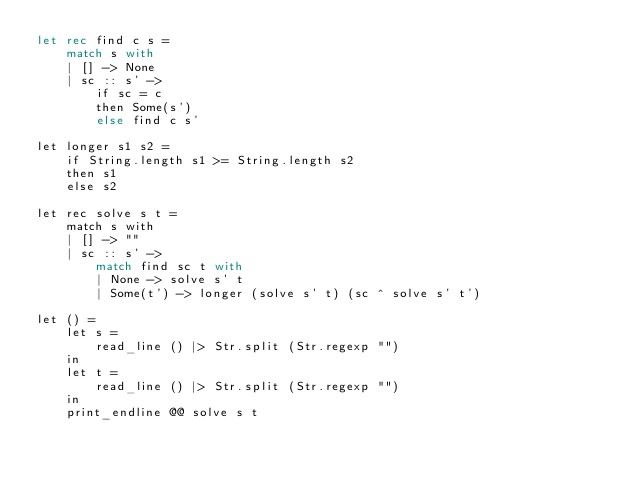<code> <loc_0><loc_0><loc_500><loc_500><_OCaml_>let rec find c s =
    match s with
    | [] -> None
    | sc :: s' ->
        if sc = c
        then Some(s')
        else find c s'

let longer s1 s2 =
    if String.length s1 >= String.length s2
    then s1
    else s2

let rec solve s t =
    match s with
    | [] -> ""
    | sc :: s' ->
        match find sc t with
        | None -> solve s' t
        | Some(t') -> longer (solve s' t) (sc ^ solve s' t')

let () =
    let s =
        read_line () |> Str.split (Str.regexp "")
    in
    let t =
        read_line () |> Str.split (Str.regexp "")
    in
    print_endline @@ solve s t
</code> 